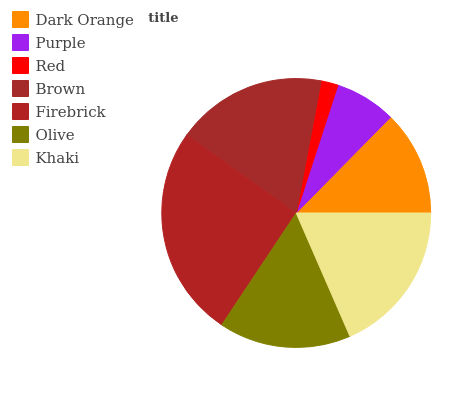Is Red the minimum?
Answer yes or no. Yes. Is Firebrick the maximum?
Answer yes or no. Yes. Is Purple the minimum?
Answer yes or no. No. Is Purple the maximum?
Answer yes or no. No. Is Dark Orange greater than Purple?
Answer yes or no. Yes. Is Purple less than Dark Orange?
Answer yes or no. Yes. Is Purple greater than Dark Orange?
Answer yes or no. No. Is Dark Orange less than Purple?
Answer yes or no. No. Is Olive the high median?
Answer yes or no. Yes. Is Olive the low median?
Answer yes or no. Yes. Is Firebrick the high median?
Answer yes or no. No. Is Purple the low median?
Answer yes or no. No. 